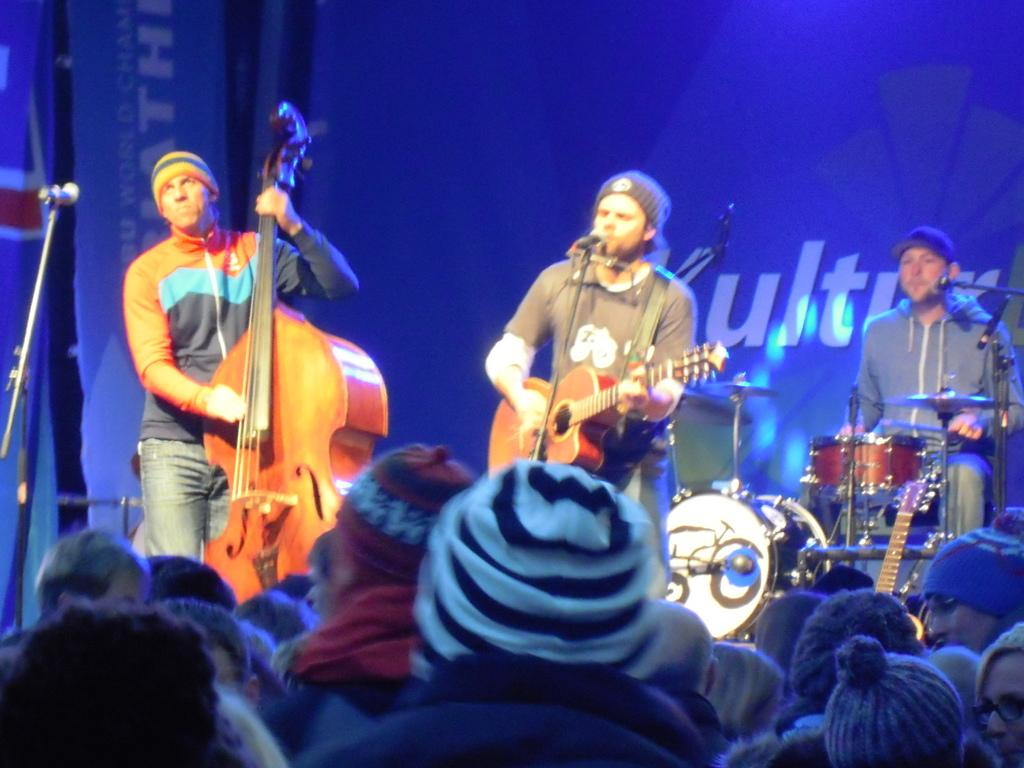What are the people in the image doing? The people sitting are watching others, while the people standing are playing musical instruments. Can you describe the actions of the people sitting? The people sitting are observing the actions of others. What are the people standing engaged in? The people standing are playing musical instruments. Can you tell me how many squirrels are playing musical instruments in the image? There are no squirrels present in the image, and therefore no such activity can be observed. 